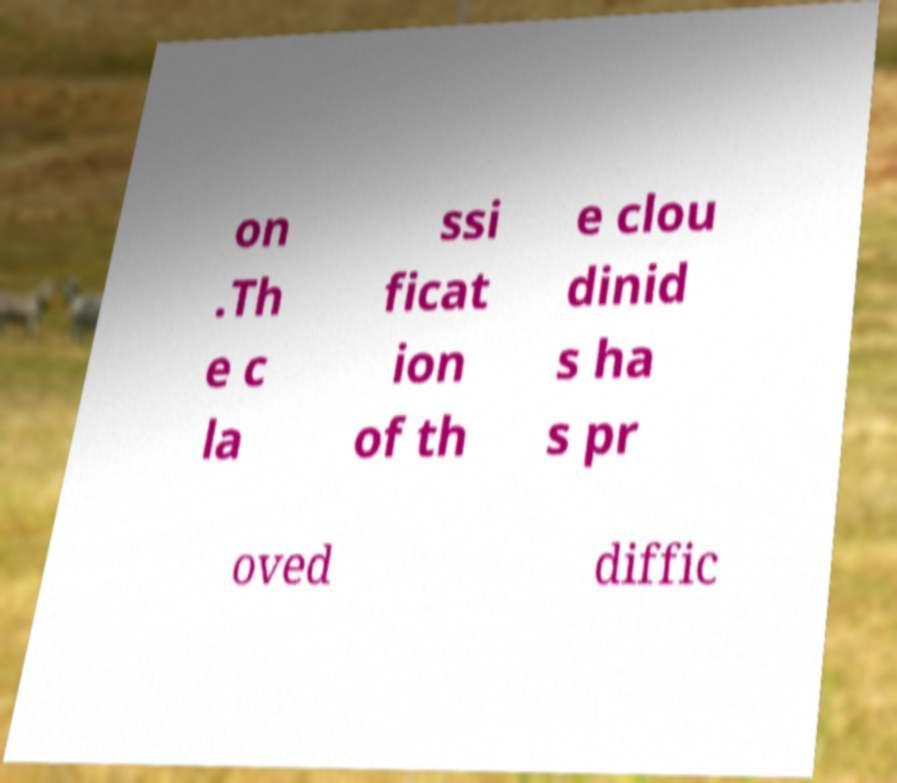For documentation purposes, I need the text within this image transcribed. Could you provide that? on .Th e c la ssi ficat ion of th e clou dinid s ha s pr oved diffic 